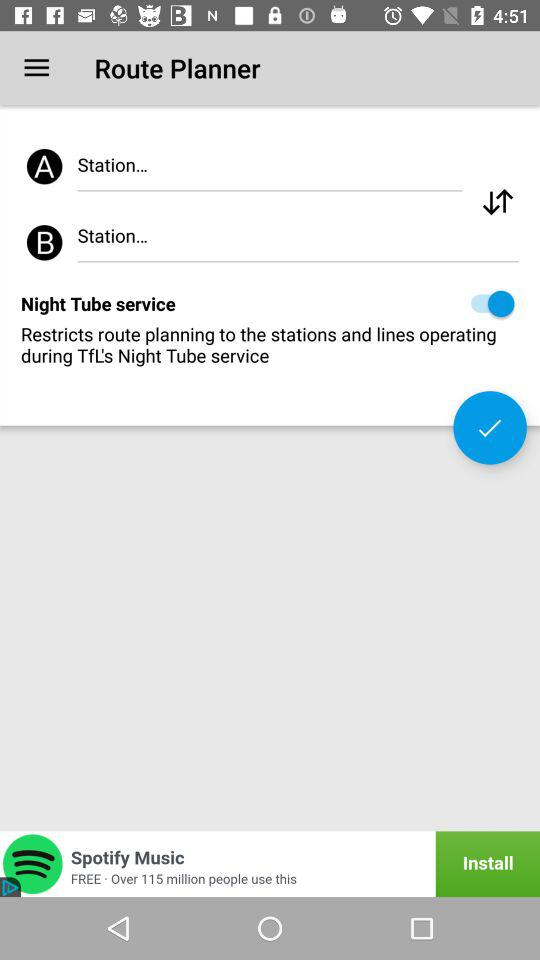How many 'Station' text inputs are present in the screen?
Answer the question using a single word or phrase. 2 